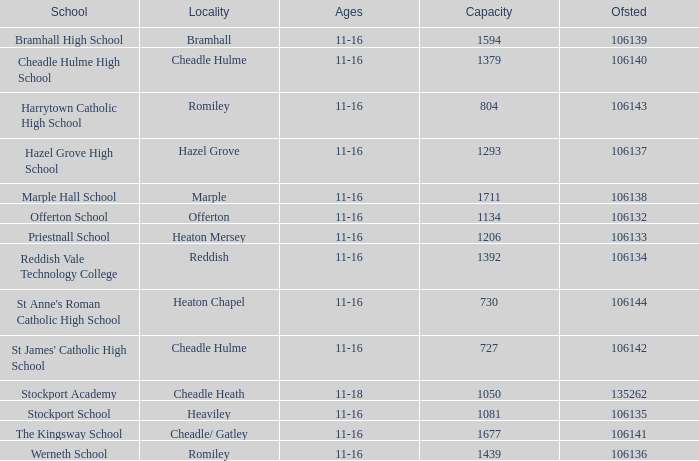What is the maximum occupancy of heaton chapel? 730.0. 